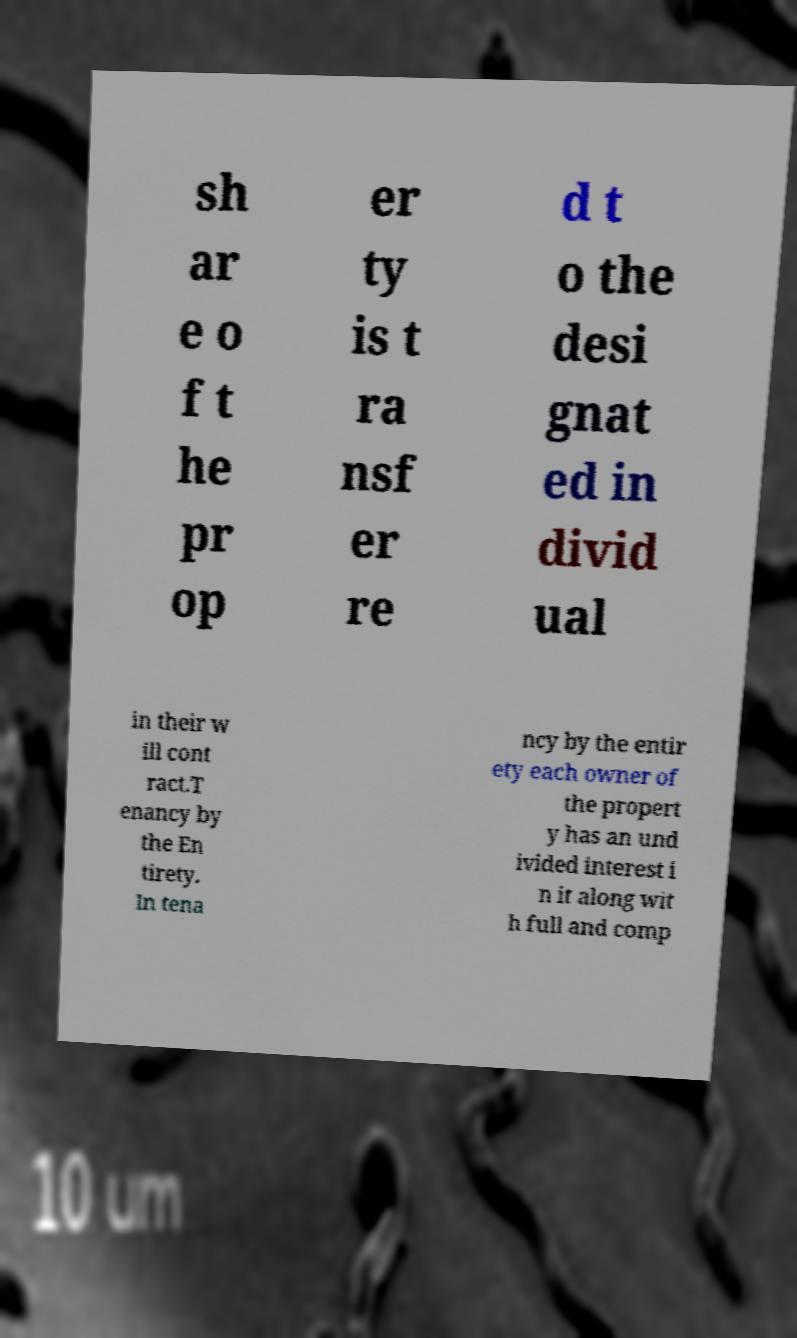I need the written content from this picture converted into text. Can you do that? sh ar e o f t he pr op er ty is t ra nsf er re d t o the desi gnat ed in divid ual in their w ill cont ract.T enancy by the En tirety. In tena ncy by the entir ety each owner of the propert y has an und ivided interest i n it along wit h full and comp 